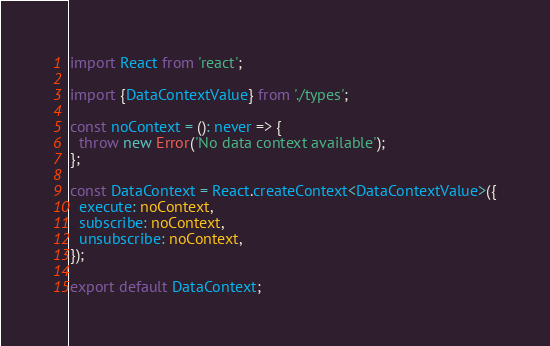Convert code to text. <code><loc_0><loc_0><loc_500><loc_500><_TypeScript_>import React from 'react';

import {DataContextValue} from './types';

const noContext = (): never => {
  throw new Error('No data context available');
};

const DataContext = React.createContext<DataContextValue>({
  execute: noContext,
  subscribe: noContext,
  unsubscribe: noContext,
});

export default DataContext;
</code> 